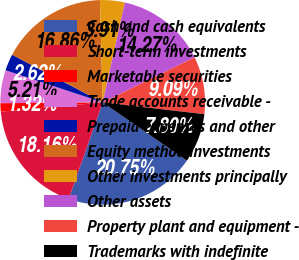Convert chart. <chart><loc_0><loc_0><loc_500><loc_500><pie_chart><fcel>Cash and cash equivalents<fcel>Short-term investments<fcel>Marketable securities<fcel>Trade accounts receivable -<fcel>Prepaid expenses and other<fcel>Equity method investments<fcel>Other investments principally<fcel>Other assets<fcel>Property plant and equipment -<fcel>Trademarks with indefinite<nl><fcel>20.75%<fcel>18.16%<fcel>1.32%<fcel>5.21%<fcel>2.62%<fcel>16.86%<fcel>3.91%<fcel>14.27%<fcel>9.09%<fcel>7.8%<nl></chart> 